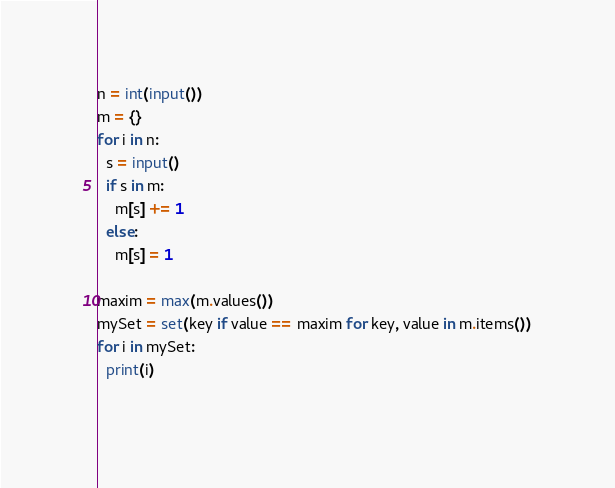Convert code to text. <code><loc_0><loc_0><loc_500><loc_500><_Python_>n = int(input())
m = {}
for i in n:
  s = input()
  if s in m:
    m[s] += 1
  else:
    m[s] = 1
    
maxim = max(m.values())
mySet = set(key if value == maxim for key, value in m.items())
for i in mySet:
  print(i)
  </code> 